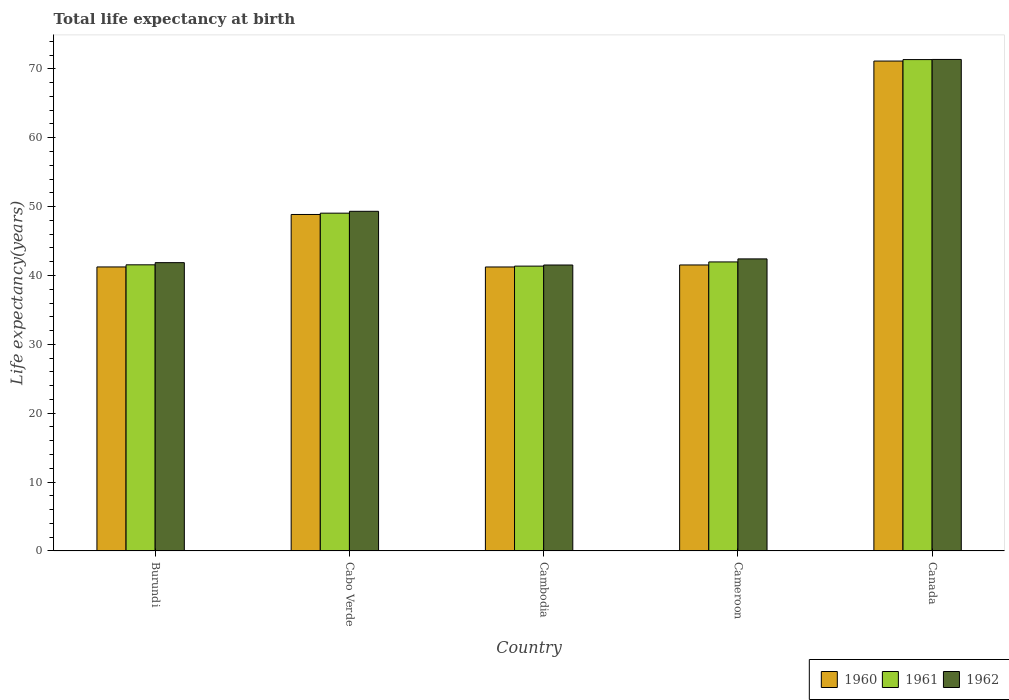How many groups of bars are there?
Keep it short and to the point. 5. Are the number of bars on each tick of the X-axis equal?
Give a very brief answer. Yes. What is the label of the 4th group of bars from the left?
Offer a very short reply. Cameroon. In how many cases, is the number of bars for a given country not equal to the number of legend labels?
Ensure brevity in your answer.  0. What is the life expectancy at birth in in 1960 in Canada?
Offer a terse response. 71.13. Across all countries, what is the maximum life expectancy at birth in in 1960?
Offer a very short reply. 71.13. Across all countries, what is the minimum life expectancy at birth in in 1961?
Give a very brief answer. 41.36. In which country was the life expectancy at birth in in 1962 maximum?
Your response must be concise. Canada. In which country was the life expectancy at birth in in 1961 minimum?
Make the answer very short. Cambodia. What is the total life expectancy at birth in in 1960 in the graph?
Your response must be concise. 243.98. What is the difference between the life expectancy at birth in in 1962 in Cabo Verde and that in Cambodia?
Provide a short and direct response. 7.8. What is the difference between the life expectancy at birth in in 1960 in Canada and the life expectancy at birth in in 1962 in Cameroon?
Ensure brevity in your answer.  28.73. What is the average life expectancy at birth in in 1960 per country?
Make the answer very short. 48.8. What is the difference between the life expectancy at birth in of/in 1960 and life expectancy at birth in of/in 1962 in Burundi?
Ensure brevity in your answer.  -0.62. In how many countries, is the life expectancy at birth in in 1961 greater than 54 years?
Your answer should be compact. 1. What is the ratio of the life expectancy at birth in in 1960 in Cabo Verde to that in Cameroon?
Provide a short and direct response. 1.18. Is the difference between the life expectancy at birth in in 1960 in Burundi and Cabo Verde greater than the difference between the life expectancy at birth in in 1962 in Burundi and Cabo Verde?
Offer a terse response. No. What is the difference between the highest and the second highest life expectancy at birth in in 1962?
Offer a very short reply. 6.91. What is the difference between the highest and the lowest life expectancy at birth in in 1960?
Provide a succinct answer. 29.9. In how many countries, is the life expectancy at birth in in 1961 greater than the average life expectancy at birth in in 1961 taken over all countries?
Your answer should be very brief. 1. Is the sum of the life expectancy at birth in in 1962 in Burundi and Canada greater than the maximum life expectancy at birth in in 1960 across all countries?
Provide a short and direct response. Yes. What does the 1st bar from the left in Cameroon represents?
Your answer should be very brief. 1960. Is it the case that in every country, the sum of the life expectancy at birth in in 1961 and life expectancy at birth in in 1962 is greater than the life expectancy at birth in in 1960?
Offer a terse response. Yes. How many countries are there in the graph?
Ensure brevity in your answer.  5. Does the graph contain grids?
Provide a short and direct response. No. Where does the legend appear in the graph?
Your response must be concise. Bottom right. How are the legend labels stacked?
Offer a very short reply. Horizontal. What is the title of the graph?
Provide a succinct answer. Total life expectancy at birth. Does "1982" appear as one of the legend labels in the graph?
Your response must be concise. No. What is the label or title of the Y-axis?
Your answer should be compact. Life expectancy(years). What is the Life expectancy(years) of 1960 in Burundi?
Provide a succinct answer. 41.24. What is the Life expectancy(years) of 1961 in Burundi?
Keep it short and to the point. 41.55. What is the Life expectancy(years) in 1962 in Burundi?
Give a very brief answer. 41.86. What is the Life expectancy(years) in 1960 in Cabo Verde?
Your answer should be very brief. 48.86. What is the Life expectancy(years) in 1961 in Cabo Verde?
Your answer should be compact. 49.05. What is the Life expectancy(years) in 1962 in Cabo Verde?
Provide a succinct answer. 49.32. What is the Life expectancy(years) of 1960 in Cambodia?
Make the answer very short. 41.23. What is the Life expectancy(years) in 1961 in Cambodia?
Ensure brevity in your answer.  41.36. What is the Life expectancy(years) in 1962 in Cambodia?
Your response must be concise. 41.52. What is the Life expectancy(years) in 1960 in Cameroon?
Your answer should be compact. 41.52. What is the Life expectancy(years) in 1961 in Cameroon?
Your response must be concise. 41.97. What is the Life expectancy(years) of 1962 in Cameroon?
Make the answer very short. 42.41. What is the Life expectancy(years) of 1960 in Canada?
Your response must be concise. 71.13. What is the Life expectancy(years) of 1961 in Canada?
Give a very brief answer. 71.35. What is the Life expectancy(years) in 1962 in Canada?
Your response must be concise. 71.37. Across all countries, what is the maximum Life expectancy(years) of 1960?
Provide a succinct answer. 71.13. Across all countries, what is the maximum Life expectancy(years) of 1961?
Give a very brief answer. 71.35. Across all countries, what is the maximum Life expectancy(years) in 1962?
Make the answer very short. 71.37. Across all countries, what is the minimum Life expectancy(years) of 1960?
Your response must be concise. 41.23. Across all countries, what is the minimum Life expectancy(years) of 1961?
Provide a short and direct response. 41.36. Across all countries, what is the minimum Life expectancy(years) of 1962?
Ensure brevity in your answer.  41.52. What is the total Life expectancy(years) of 1960 in the graph?
Provide a short and direct response. 243.98. What is the total Life expectancy(years) of 1961 in the graph?
Provide a succinct answer. 245.26. What is the total Life expectancy(years) of 1962 in the graph?
Provide a short and direct response. 246.47. What is the difference between the Life expectancy(years) of 1960 in Burundi and that in Cabo Verde?
Your answer should be very brief. -7.62. What is the difference between the Life expectancy(years) of 1961 in Burundi and that in Cabo Verde?
Provide a succinct answer. -7.5. What is the difference between the Life expectancy(years) of 1962 in Burundi and that in Cabo Verde?
Your response must be concise. -7.46. What is the difference between the Life expectancy(years) in 1960 in Burundi and that in Cambodia?
Keep it short and to the point. 0. What is the difference between the Life expectancy(years) in 1961 in Burundi and that in Cambodia?
Keep it short and to the point. 0.19. What is the difference between the Life expectancy(years) in 1962 in Burundi and that in Cambodia?
Offer a very short reply. 0.34. What is the difference between the Life expectancy(years) of 1960 in Burundi and that in Cameroon?
Provide a succinct answer. -0.29. What is the difference between the Life expectancy(years) in 1961 in Burundi and that in Cameroon?
Your response must be concise. -0.42. What is the difference between the Life expectancy(years) of 1962 in Burundi and that in Cameroon?
Provide a succinct answer. -0.55. What is the difference between the Life expectancy(years) of 1960 in Burundi and that in Canada?
Make the answer very short. -29.9. What is the difference between the Life expectancy(years) of 1961 in Burundi and that in Canada?
Make the answer very short. -29.8. What is the difference between the Life expectancy(years) of 1962 in Burundi and that in Canada?
Provide a short and direct response. -29.51. What is the difference between the Life expectancy(years) in 1960 in Cabo Verde and that in Cambodia?
Offer a terse response. 7.62. What is the difference between the Life expectancy(years) of 1961 in Cabo Verde and that in Cambodia?
Your answer should be compact. 7.69. What is the difference between the Life expectancy(years) of 1962 in Cabo Verde and that in Cambodia?
Your answer should be compact. 7.8. What is the difference between the Life expectancy(years) of 1960 in Cabo Verde and that in Cameroon?
Give a very brief answer. 7.33. What is the difference between the Life expectancy(years) in 1961 in Cabo Verde and that in Cameroon?
Your response must be concise. 7.08. What is the difference between the Life expectancy(years) of 1962 in Cabo Verde and that in Cameroon?
Offer a very short reply. 6.91. What is the difference between the Life expectancy(years) of 1960 in Cabo Verde and that in Canada?
Provide a succinct answer. -22.28. What is the difference between the Life expectancy(years) of 1961 in Cabo Verde and that in Canada?
Provide a short and direct response. -22.3. What is the difference between the Life expectancy(years) of 1962 in Cabo Verde and that in Canada?
Your response must be concise. -22.05. What is the difference between the Life expectancy(years) in 1960 in Cambodia and that in Cameroon?
Your response must be concise. -0.29. What is the difference between the Life expectancy(years) of 1961 in Cambodia and that in Cameroon?
Provide a short and direct response. -0.61. What is the difference between the Life expectancy(years) of 1962 in Cambodia and that in Cameroon?
Give a very brief answer. -0.89. What is the difference between the Life expectancy(years) of 1960 in Cambodia and that in Canada?
Make the answer very short. -29.9. What is the difference between the Life expectancy(years) of 1961 in Cambodia and that in Canada?
Offer a very short reply. -29.99. What is the difference between the Life expectancy(years) of 1962 in Cambodia and that in Canada?
Keep it short and to the point. -29.85. What is the difference between the Life expectancy(years) in 1960 in Cameroon and that in Canada?
Offer a terse response. -29.61. What is the difference between the Life expectancy(years) of 1961 in Cameroon and that in Canada?
Your response must be concise. -29.38. What is the difference between the Life expectancy(years) in 1962 in Cameroon and that in Canada?
Make the answer very short. -28.96. What is the difference between the Life expectancy(years) in 1960 in Burundi and the Life expectancy(years) in 1961 in Cabo Verde?
Provide a succinct answer. -7.81. What is the difference between the Life expectancy(years) in 1960 in Burundi and the Life expectancy(years) in 1962 in Cabo Verde?
Make the answer very short. -8.08. What is the difference between the Life expectancy(years) in 1961 in Burundi and the Life expectancy(years) in 1962 in Cabo Verde?
Keep it short and to the point. -7.77. What is the difference between the Life expectancy(years) of 1960 in Burundi and the Life expectancy(years) of 1961 in Cambodia?
Give a very brief answer. -0.12. What is the difference between the Life expectancy(years) in 1960 in Burundi and the Life expectancy(years) in 1962 in Cambodia?
Ensure brevity in your answer.  -0.28. What is the difference between the Life expectancy(years) of 1961 in Burundi and the Life expectancy(years) of 1962 in Cambodia?
Provide a succinct answer. 0.03. What is the difference between the Life expectancy(years) in 1960 in Burundi and the Life expectancy(years) in 1961 in Cameroon?
Your answer should be compact. -0.73. What is the difference between the Life expectancy(years) of 1960 in Burundi and the Life expectancy(years) of 1962 in Cameroon?
Your response must be concise. -1.17. What is the difference between the Life expectancy(years) in 1961 in Burundi and the Life expectancy(years) in 1962 in Cameroon?
Offer a very short reply. -0.86. What is the difference between the Life expectancy(years) of 1960 in Burundi and the Life expectancy(years) of 1961 in Canada?
Ensure brevity in your answer.  -30.11. What is the difference between the Life expectancy(years) in 1960 in Burundi and the Life expectancy(years) in 1962 in Canada?
Keep it short and to the point. -30.13. What is the difference between the Life expectancy(years) in 1961 in Burundi and the Life expectancy(years) in 1962 in Canada?
Your answer should be compact. -29.82. What is the difference between the Life expectancy(years) in 1960 in Cabo Verde and the Life expectancy(years) in 1961 in Cambodia?
Keep it short and to the point. 7.5. What is the difference between the Life expectancy(years) in 1960 in Cabo Verde and the Life expectancy(years) in 1962 in Cambodia?
Make the answer very short. 7.34. What is the difference between the Life expectancy(years) in 1961 in Cabo Verde and the Life expectancy(years) in 1962 in Cambodia?
Give a very brief answer. 7.53. What is the difference between the Life expectancy(years) in 1960 in Cabo Verde and the Life expectancy(years) in 1961 in Cameroon?
Your answer should be compact. 6.89. What is the difference between the Life expectancy(years) in 1960 in Cabo Verde and the Life expectancy(years) in 1962 in Cameroon?
Offer a very short reply. 6.45. What is the difference between the Life expectancy(years) of 1961 in Cabo Verde and the Life expectancy(years) of 1962 in Cameroon?
Offer a terse response. 6.64. What is the difference between the Life expectancy(years) of 1960 in Cabo Verde and the Life expectancy(years) of 1961 in Canada?
Your response must be concise. -22.49. What is the difference between the Life expectancy(years) in 1960 in Cabo Verde and the Life expectancy(years) in 1962 in Canada?
Your answer should be compact. -22.51. What is the difference between the Life expectancy(years) of 1961 in Cabo Verde and the Life expectancy(years) of 1962 in Canada?
Offer a very short reply. -22.32. What is the difference between the Life expectancy(years) in 1960 in Cambodia and the Life expectancy(years) in 1961 in Cameroon?
Your answer should be very brief. -0.73. What is the difference between the Life expectancy(years) in 1960 in Cambodia and the Life expectancy(years) in 1962 in Cameroon?
Provide a succinct answer. -1.17. What is the difference between the Life expectancy(years) in 1961 in Cambodia and the Life expectancy(years) in 1962 in Cameroon?
Provide a succinct answer. -1.05. What is the difference between the Life expectancy(years) in 1960 in Cambodia and the Life expectancy(years) in 1961 in Canada?
Offer a terse response. -30.11. What is the difference between the Life expectancy(years) of 1960 in Cambodia and the Life expectancy(years) of 1962 in Canada?
Your response must be concise. -30.14. What is the difference between the Life expectancy(years) in 1961 in Cambodia and the Life expectancy(years) in 1962 in Canada?
Give a very brief answer. -30.01. What is the difference between the Life expectancy(years) of 1960 in Cameroon and the Life expectancy(years) of 1961 in Canada?
Provide a succinct answer. -29.82. What is the difference between the Life expectancy(years) in 1960 in Cameroon and the Life expectancy(years) in 1962 in Canada?
Offer a very short reply. -29.84. What is the difference between the Life expectancy(years) of 1961 in Cameroon and the Life expectancy(years) of 1962 in Canada?
Your response must be concise. -29.4. What is the average Life expectancy(years) of 1960 per country?
Ensure brevity in your answer.  48.8. What is the average Life expectancy(years) in 1961 per country?
Make the answer very short. 49.05. What is the average Life expectancy(years) in 1962 per country?
Keep it short and to the point. 49.29. What is the difference between the Life expectancy(years) of 1960 and Life expectancy(years) of 1961 in Burundi?
Offer a terse response. -0.31. What is the difference between the Life expectancy(years) of 1960 and Life expectancy(years) of 1962 in Burundi?
Ensure brevity in your answer.  -0.62. What is the difference between the Life expectancy(years) of 1961 and Life expectancy(years) of 1962 in Burundi?
Your answer should be very brief. -0.31. What is the difference between the Life expectancy(years) in 1960 and Life expectancy(years) in 1961 in Cabo Verde?
Ensure brevity in your answer.  -0.19. What is the difference between the Life expectancy(years) of 1960 and Life expectancy(years) of 1962 in Cabo Verde?
Your answer should be compact. -0.46. What is the difference between the Life expectancy(years) of 1961 and Life expectancy(years) of 1962 in Cabo Verde?
Provide a succinct answer. -0.27. What is the difference between the Life expectancy(years) in 1960 and Life expectancy(years) in 1961 in Cambodia?
Your answer should be very brief. -0.13. What is the difference between the Life expectancy(years) of 1960 and Life expectancy(years) of 1962 in Cambodia?
Make the answer very short. -0.29. What is the difference between the Life expectancy(years) of 1961 and Life expectancy(years) of 1962 in Cambodia?
Offer a terse response. -0.16. What is the difference between the Life expectancy(years) of 1960 and Life expectancy(years) of 1961 in Cameroon?
Your response must be concise. -0.44. What is the difference between the Life expectancy(years) in 1960 and Life expectancy(years) in 1962 in Cameroon?
Ensure brevity in your answer.  -0.88. What is the difference between the Life expectancy(years) in 1961 and Life expectancy(years) in 1962 in Cameroon?
Keep it short and to the point. -0.44. What is the difference between the Life expectancy(years) in 1960 and Life expectancy(years) in 1961 in Canada?
Ensure brevity in your answer.  -0.21. What is the difference between the Life expectancy(years) of 1960 and Life expectancy(years) of 1962 in Canada?
Ensure brevity in your answer.  -0.23. What is the difference between the Life expectancy(years) in 1961 and Life expectancy(years) in 1962 in Canada?
Make the answer very short. -0.02. What is the ratio of the Life expectancy(years) in 1960 in Burundi to that in Cabo Verde?
Provide a short and direct response. 0.84. What is the ratio of the Life expectancy(years) in 1961 in Burundi to that in Cabo Verde?
Your response must be concise. 0.85. What is the ratio of the Life expectancy(years) of 1962 in Burundi to that in Cabo Verde?
Provide a succinct answer. 0.85. What is the ratio of the Life expectancy(years) of 1961 in Burundi to that in Cambodia?
Offer a terse response. 1. What is the ratio of the Life expectancy(years) in 1962 in Burundi to that in Cambodia?
Provide a short and direct response. 1.01. What is the ratio of the Life expectancy(years) in 1960 in Burundi to that in Cameroon?
Keep it short and to the point. 0.99. What is the ratio of the Life expectancy(years) in 1961 in Burundi to that in Cameroon?
Offer a terse response. 0.99. What is the ratio of the Life expectancy(years) in 1962 in Burundi to that in Cameroon?
Keep it short and to the point. 0.99. What is the ratio of the Life expectancy(years) in 1960 in Burundi to that in Canada?
Your answer should be compact. 0.58. What is the ratio of the Life expectancy(years) in 1961 in Burundi to that in Canada?
Offer a terse response. 0.58. What is the ratio of the Life expectancy(years) of 1962 in Burundi to that in Canada?
Your answer should be compact. 0.59. What is the ratio of the Life expectancy(years) in 1960 in Cabo Verde to that in Cambodia?
Your answer should be very brief. 1.18. What is the ratio of the Life expectancy(years) of 1961 in Cabo Verde to that in Cambodia?
Give a very brief answer. 1.19. What is the ratio of the Life expectancy(years) of 1962 in Cabo Verde to that in Cambodia?
Provide a succinct answer. 1.19. What is the ratio of the Life expectancy(years) in 1960 in Cabo Verde to that in Cameroon?
Keep it short and to the point. 1.18. What is the ratio of the Life expectancy(years) of 1961 in Cabo Verde to that in Cameroon?
Give a very brief answer. 1.17. What is the ratio of the Life expectancy(years) in 1962 in Cabo Verde to that in Cameroon?
Offer a very short reply. 1.16. What is the ratio of the Life expectancy(years) in 1960 in Cabo Verde to that in Canada?
Offer a very short reply. 0.69. What is the ratio of the Life expectancy(years) of 1961 in Cabo Verde to that in Canada?
Your response must be concise. 0.69. What is the ratio of the Life expectancy(years) in 1962 in Cabo Verde to that in Canada?
Your response must be concise. 0.69. What is the ratio of the Life expectancy(years) in 1961 in Cambodia to that in Cameroon?
Your answer should be compact. 0.99. What is the ratio of the Life expectancy(years) of 1962 in Cambodia to that in Cameroon?
Ensure brevity in your answer.  0.98. What is the ratio of the Life expectancy(years) in 1960 in Cambodia to that in Canada?
Make the answer very short. 0.58. What is the ratio of the Life expectancy(years) in 1961 in Cambodia to that in Canada?
Offer a terse response. 0.58. What is the ratio of the Life expectancy(years) of 1962 in Cambodia to that in Canada?
Give a very brief answer. 0.58. What is the ratio of the Life expectancy(years) in 1960 in Cameroon to that in Canada?
Your answer should be very brief. 0.58. What is the ratio of the Life expectancy(years) in 1961 in Cameroon to that in Canada?
Keep it short and to the point. 0.59. What is the ratio of the Life expectancy(years) of 1962 in Cameroon to that in Canada?
Offer a terse response. 0.59. What is the difference between the highest and the second highest Life expectancy(years) of 1960?
Your answer should be compact. 22.28. What is the difference between the highest and the second highest Life expectancy(years) of 1961?
Make the answer very short. 22.3. What is the difference between the highest and the second highest Life expectancy(years) of 1962?
Make the answer very short. 22.05. What is the difference between the highest and the lowest Life expectancy(years) of 1960?
Your answer should be compact. 29.9. What is the difference between the highest and the lowest Life expectancy(years) of 1961?
Your response must be concise. 29.99. What is the difference between the highest and the lowest Life expectancy(years) in 1962?
Your answer should be compact. 29.85. 